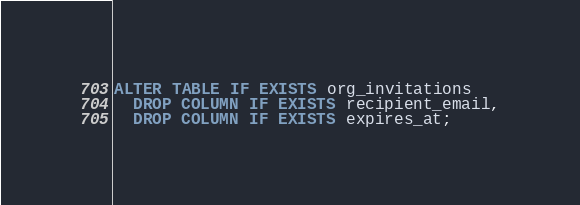Convert code to text. <code><loc_0><loc_0><loc_500><loc_500><_SQL_>ALTER TABLE IF EXISTS org_invitations
  DROP COLUMN IF EXISTS recipient_email,
  DROP COLUMN IF EXISTS expires_at;
</code> 